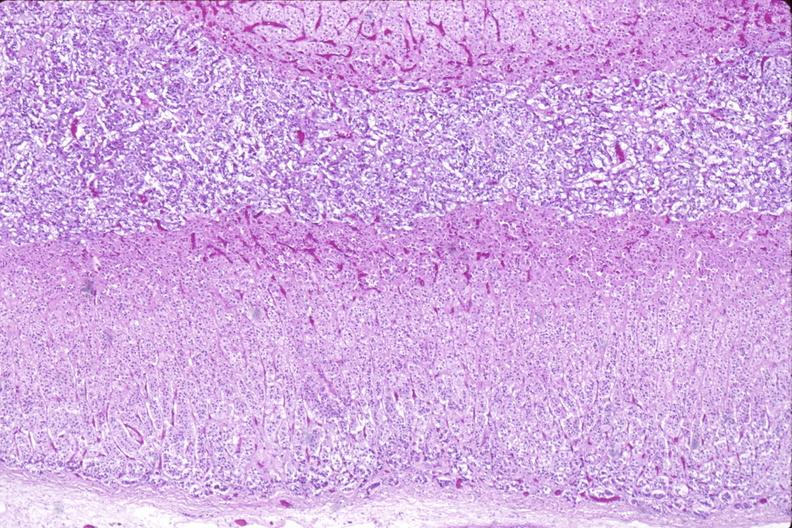s endocrine present?
Answer the question using a single word or phrase. Yes 